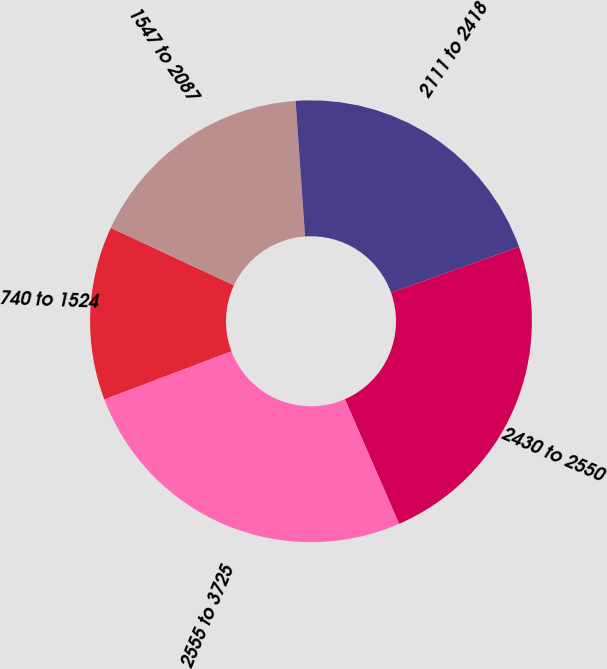Convert chart. <chart><loc_0><loc_0><loc_500><loc_500><pie_chart><fcel>740 to 1524<fcel>1547 to 2087<fcel>2111 to 2418<fcel>2430 to 2550<fcel>2555 to 3725<nl><fcel>12.71%<fcel>16.94%<fcel>20.65%<fcel>23.93%<fcel>25.77%<nl></chart> 